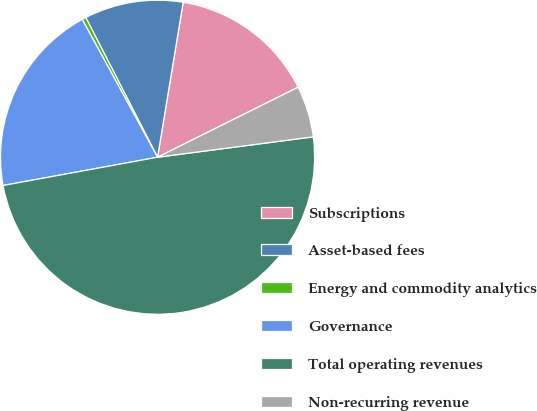Convert chart. <chart><loc_0><loc_0><loc_500><loc_500><pie_chart><fcel>Subscriptions<fcel>Asset-based fees<fcel>Energy and commodity analytics<fcel>Governance<fcel>Total operating revenues<fcel>Non-recurring revenue<nl><fcel>15.04%<fcel>10.16%<fcel>0.41%<fcel>19.92%<fcel>49.19%<fcel>5.28%<nl></chart> 